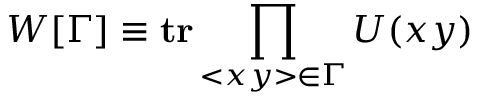Convert formula to latex. <formula><loc_0><loc_0><loc_500><loc_500>W [ \Gamma ] \equiv t r \prod _ { < x y > \in \Gamma } U ( x y )</formula> 